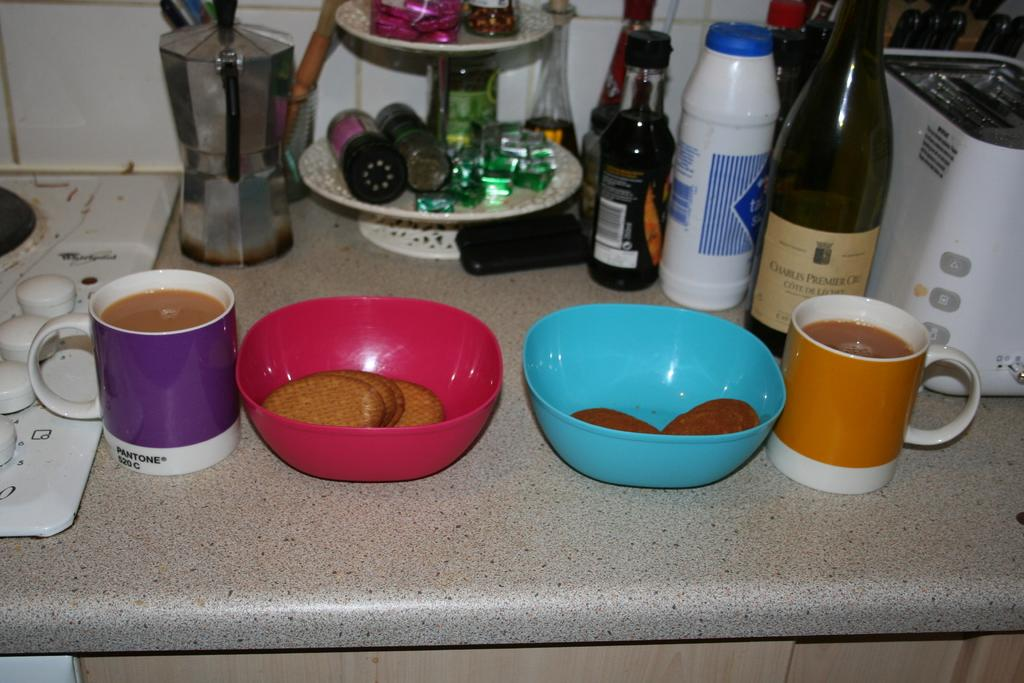How many cups are visible in the image? There are two cups in the image. What accompanies the cups in the image? There are two bowls of biscuits in the image. What can be seen in the background of the image? There is a wine bottle and an electronic device in the background of the image. What type of plastic material is used to make the argument in the image? There is no argument present in the image, and no plastic material is mentioned in the facts provided. 